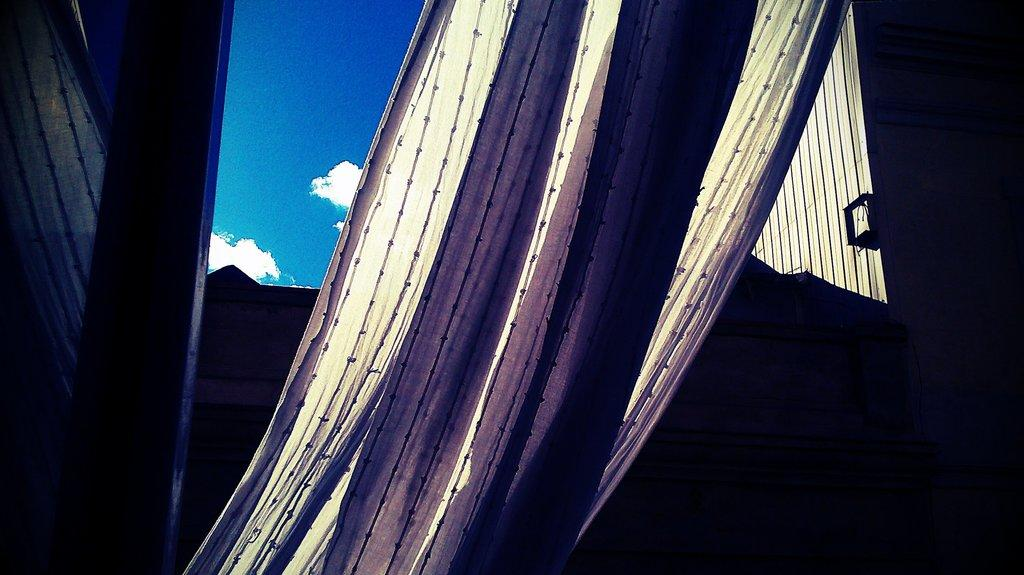What is the main object in the center of the image? There is an object in the center of the image that appears to be a curtain. What else can be seen in the image besides the curtain? There are other objects visible in the image. What is visible in the background of the image? The sky is visible in the background of the image. What can be observed in the sky? Clouds are present in the sky. How many branches can be seen on the curtain in the image? There are no branches visible on the curtain in the image. 